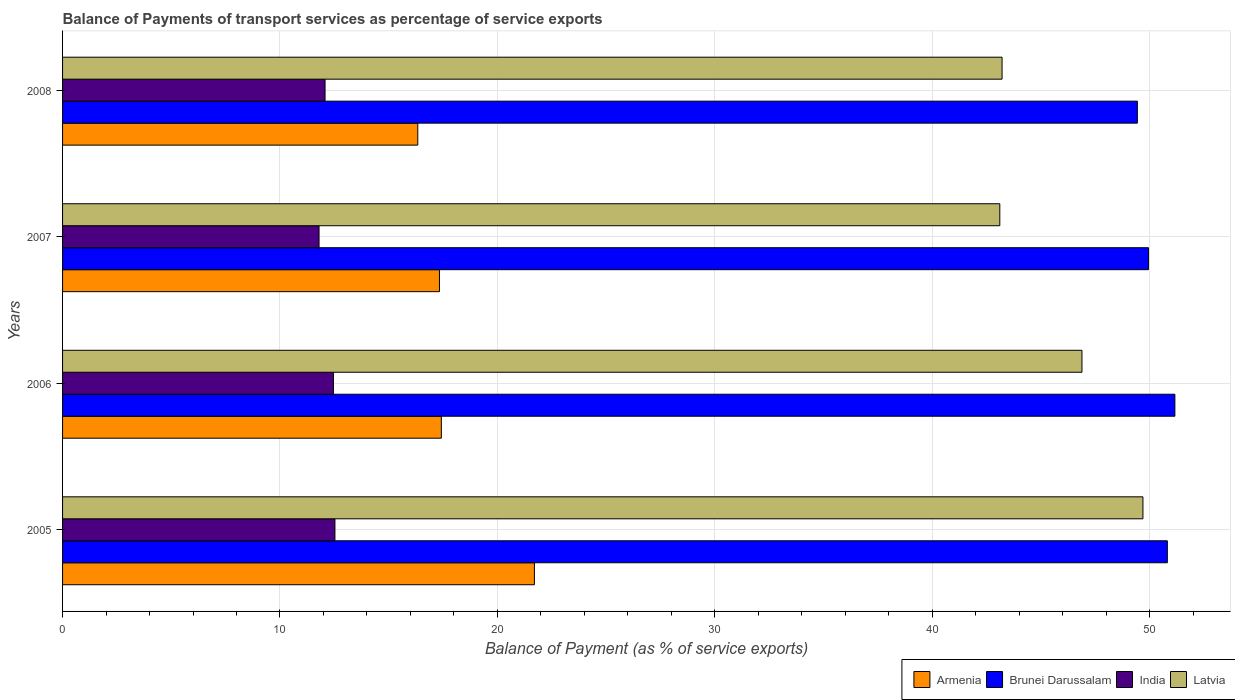How many groups of bars are there?
Make the answer very short. 4. Are the number of bars per tick equal to the number of legend labels?
Your response must be concise. Yes. Are the number of bars on each tick of the Y-axis equal?
Offer a terse response. Yes. How many bars are there on the 4th tick from the top?
Make the answer very short. 4. What is the balance of payments of transport services in India in 2007?
Your response must be concise. 11.8. Across all years, what is the maximum balance of payments of transport services in Armenia?
Keep it short and to the point. 21.7. Across all years, what is the minimum balance of payments of transport services in Latvia?
Keep it short and to the point. 43.11. In which year was the balance of payments of transport services in Brunei Darussalam maximum?
Your answer should be compact. 2006. In which year was the balance of payments of transport services in Latvia minimum?
Ensure brevity in your answer.  2007. What is the total balance of payments of transport services in Armenia in the graph?
Your response must be concise. 72.8. What is the difference between the balance of payments of transport services in Armenia in 2006 and that in 2007?
Ensure brevity in your answer.  0.09. What is the difference between the balance of payments of transport services in Brunei Darussalam in 2006 and the balance of payments of transport services in Latvia in 2005?
Keep it short and to the point. 1.47. What is the average balance of payments of transport services in India per year?
Give a very brief answer. 12.21. In the year 2008, what is the difference between the balance of payments of transport services in Latvia and balance of payments of transport services in India?
Keep it short and to the point. 31.14. In how many years, is the balance of payments of transport services in Brunei Darussalam greater than 26 %?
Your answer should be compact. 4. What is the ratio of the balance of payments of transport services in Brunei Darussalam in 2005 to that in 2006?
Give a very brief answer. 0.99. Is the balance of payments of transport services in India in 2005 less than that in 2006?
Give a very brief answer. No. Is the difference between the balance of payments of transport services in Latvia in 2006 and 2007 greater than the difference between the balance of payments of transport services in India in 2006 and 2007?
Your response must be concise. Yes. What is the difference between the highest and the second highest balance of payments of transport services in Latvia?
Give a very brief answer. 2.8. What is the difference between the highest and the lowest balance of payments of transport services in Brunei Darussalam?
Give a very brief answer. 1.73. In how many years, is the balance of payments of transport services in Latvia greater than the average balance of payments of transport services in Latvia taken over all years?
Ensure brevity in your answer.  2. Is the sum of the balance of payments of transport services in Brunei Darussalam in 2005 and 2006 greater than the maximum balance of payments of transport services in Latvia across all years?
Offer a very short reply. Yes. Is it the case that in every year, the sum of the balance of payments of transport services in Brunei Darussalam and balance of payments of transport services in Latvia is greater than the sum of balance of payments of transport services in Armenia and balance of payments of transport services in India?
Provide a short and direct response. Yes. What does the 4th bar from the top in 2007 represents?
Give a very brief answer. Armenia. What does the 2nd bar from the bottom in 2008 represents?
Provide a succinct answer. Brunei Darussalam. Are the values on the major ticks of X-axis written in scientific E-notation?
Ensure brevity in your answer.  No. Does the graph contain grids?
Ensure brevity in your answer.  Yes. How many legend labels are there?
Make the answer very short. 4. What is the title of the graph?
Provide a short and direct response. Balance of Payments of transport services as percentage of service exports. Does "Vanuatu" appear as one of the legend labels in the graph?
Offer a terse response. No. What is the label or title of the X-axis?
Provide a succinct answer. Balance of Payment (as % of service exports). What is the label or title of the Y-axis?
Ensure brevity in your answer.  Years. What is the Balance of Payment (as % of service exports) in Armenia in 2005?
Your response must be concise. 21.7. What is the Balance of Payment (as % of service exports) of Brunei Darussalam in 2005?
Provide a succinct answer. 50.81. What is the Balance of Payment (as % of service exports) of India in 2005?
Provide a succinct answer. 12.53. What is the Balance of Payment (as % of service exports) of Latvia in 2005?
Keep it short and to the point. 49.69. What is the Balance of Payment (as % of service exports) in Armenia in 2006?
Your answer should be very brief. 17.42. What is the Balance of Payment (as % of service exports) in Brunei Darussalam in 2006?
Provide a short and direct response. 51.16. What is the Balance of Payment (as % of service exports) in India in 2006?
Ensure brevity in your answer.  12.46. What is the Balance of Payment (as % of service exports) of Latvia in 2006?
Your answer should be very brief. 46.89. What is the Balance of Payment (as % of service exports) of Armenia in 2007?
Keep it short and to the point. 17.34. What is the Balance of Payment (as % of service exports) of Brunei Darussalam in 2007?
Your answer should be compact. 49.95. What is the Balance of Payment (as % of service exports) of India in 2007?
Keep it short and to the point. 11.8. What is the Balance of Payment (as % of service exports) of Latvia in 2007?
Give a very brief answer. 43.11. What is the Balance of Payment (as % of service exports) of Armenia in 2008?
Provide a short and direct response. 16.34. What is the Balance of Payment (as % of service exports) in Brunei Darussalam in 2008?
Give a very brief answer. 49.44. What is the Balance of Payment (as % of service exports) in India in 2008?
Your answer should be very brief. 12.07. What is the Balance of Payment (as % of service exports) of Latvia in 2008?
Offer a terse response. 43.21. Across all years, what is the maximum Balance of Payment (as % of service exports) of Armenia?
Your answer should be very brief. 21.7. Across all years, what is the maximum Balance of Payment (as % of service exports) in Brunei Darussalam?
Ensure brevity in your answer.  51.16. Across all years, what is the maximum Balance of Payment (as % of service exports) of India?
Make the answer very short. 12.53. Across all years, what is the maximum Balance of Payment (as % of service exports) of Latvia?
Ensure brevity in your answer.  49.69. Across all years, what is the minimum Balance of Payment (as % of service exports) of Armenia?
Your answer should be very brief. 16.34. Across all years, what is the minimum Balance of Payment (as % of service exports) of Brunei Darussalam?
Keep it short and to the point. 49.44. Across all years, what is the minimum Balance of Payment (as % of service exports) in India?
Your answer should be very brief. 11.8. Across all years, what is the minimum Balance of Payment (as % of service exports) in Latvia?
Keep it short and to the point. 43.11. What is the total Balance of Payment (as % of service exports) in Armenia in the graph?
Keep it short and to the point. 72.8. What is the total Balance of Payment (as % of service exports) of Brunei Darussalam in the graph?
Keep it short and to the point. 201.36. What is the total Balance of Payment (as % of service exports) in India in the graph?
Your answer should be compact. 48.86. What is the total Balance of Payment (as % of service exports) in Latvia in the graph?
Your answer should be compact. 182.9. What is the difference between the Balance of Payment (as % of service exports) in Armenia in 2005 and that in 2006?
Offer a very short reply. 4.28. What is the difference between the Balance of Payment (as % of service exports) of Brunei Darussalam in 2005 and that in 2006?
Ensure brevity in your answer.  -0.35. What is the difference between the Balance of Payment (as % of service exports) of India in 2005 and that in 2006?
Provide a short and direct response. 0.07. What is the difference between the Balance of Payment (as % of service exports) in Latvia in 2005 and that in 2006?
Give a very brief answer. 2.8. What is the difference between the Balance of Payment (as % of service exports) of Armenia in 2005 and that in 2007?
Keep it short and to the point. 4.37. What is the difference between the Balance of Payment (as % of service exports) in Brunei Darussalam in 2005 and that in 2007?
Your answer should be very brief. 0.86. What is the difference between the Balance of Payment (as % of service exports) of India in 2005 and that in 2007?
Give a very brief answer. 0.73. What is the difference between the Balance of Payment (as % of service exports) in Latvia in 2005 and that in 2007?
Offer a very short reply. 6.58. What is the difference between the Balance of Payment (as % of service exports) of Armenia in 2005 and that in 2008?
Your response must be concise. 5.36. What is the difference between the Balance of Payment (as % of service exports) of Brunei Darussalam in 2005 and that in 2008?
Provide a succinct answer. 1.38. What is the difference between the Balance of Payment (as % of service exports) of India in 2005 and that in 2008?
Your answer should be compact. 0.45. What is the difference between the Balance of Payment (as % of service exports) in Latvia in 2005 and that in 2008?
Your response must be concise. 6.48. What is the difference between the Balance of Payment (as % of service exports) in Armenia in 2006 and that in 2007?
Offer a very short reply. 0.09. What is the difference between the Balance of Payment (as % of service exports) in Brunei Darussalam in 2006 and that in 2007?
Your answer should be compact. 1.21. What is the difference between the Balance of Payment (as % of service exports) in India in 2006 and that in 2007?
Keep it short and to the point. 0.66. What is the difference between the Balance of Payment (as % of service exports) in Latvia in 2006 and that in 2007?
Provide a succinct answer. 3.78. What is the difference between the Balance of Payment (as % of service exports) of Armenia in 2006 and that in 2008?
Make the answer very short. 1.08. What is the difference between the Balance of Payment (as % of service exports) of Brunei Darussalam in 2006 and that in 2008?
Keep it short and to the point. 1.73. What is the difference between the Balance of Payment (as % of service exports) in India in 2006 and that in 2008?
Offer a terse response. 0.39. What is the difference between the Balance of Payment (as % of service exports) in Latvia in 2006 and that in 2008?
Your response must be concise. 3.67. What is the difference between the Balance of Payment (as % of service exports) of Armenia in 2007 and that in 2008?
Ensure brevity in your answer.  1. What is the difference between the Balance of Payment (as % of service exports) in Brunei Darussalam in 2007 and that in 2008?
Make the answer very short. 0.51. What is the difference between the Balance of Payment (as % of service exports) in India in 2007 and that in 2008?
Your answer should be very brief. -0.28. What is the difference between the Balance of Payment (as % of service exports) of Latvia in 2007 and that in 2008?
Offer a very short reply. -0.1. What is the difference between the Balance of Payment (as % of service exports) of Armenia in 2005 and the Balance of Payment (as % of service exports) of Brunei Darussalam in 2006?
Offer a terse response. -29.46. What is the difference between the Balance of Payment (as % of service exports) in Armenia in 2005 and the Balance of Payment (as % of service exports) in India in 2006?
Offer a very short reply. 9.24. What is the difference between the Balance of Payment (as % of service exports) of Armenia in 2005 and the Balance of Payment (as % of service exports) of Latvia in 2006?
Your answer should be compact. -25.18. What is the difference between the Balance of Payment (as % of service exports) in Brunei Darussalam in 2005 and the Balance of Payment (as % of service exports) in India in 2006?
Provide a succinct answer. 38.36. What is the difference between the Balance of Payment (as % of service exports) in Brunei Darussalam in 2005 and the Balance of Payment (as % of service exports) in Latvia in 2006?
Your answer should be compact. 3.93. What is the difference between the Balance of Payment (as % of service exports) in India in 2005 and the Balance of Payment (as % of service exports) in Latvia in 2006?
Your response must be concise. -34.36. What is the difference between the Balance of Payment (as % of service exports) in Armenia in 2005 and the Balance of Payment (as % of service exports) in Brunei Darussalam in 2007?
Your response must be concise. -28.25. What is the difference between the Balance of Payment (as % of service exports) in Armenia in 2005 and the Balance of Payment (as % of service exports) in India in 2007?
Provide a succinct answer. 9.91. What is the difference between the Balance of Payment (as % of service exports) of Armenia in 2005 and the Balance of Payment (as % of service exports) of Latvia in 2007?
Your answer should be compact. -21.41. What is the difference between the Balance of Payment (as % of service exports) in Brunei Darussalam in 2005 and the Balance of Payment (as % of service exports) in India in 2007?
Your answer should be compact. 39.02. What is the difference between the Balance of Payment (as % of service exports) of Brunei Darussalam in 2005 and the Balance of Payment (as % of service exports) of Latvia in 2007?
Your answer should be compact. 7.71. What is the difference between the Balance of Payment (as % of service exports) of India in 2005 and the Balance of Payment (as % of service exports) of Latvia in 2007?
Ensure brevity in your answer.  -30.58. What is the difference between the Balance of Payment (as % of service exports) in Armenia in 2005 and the Balance of Payment (as % of service exports) in Brunei Darussalam in 2008?
Provide a succinct answer. -27.73. What is the difference between the Balance of Payment (as % of service exports) in Armenia in 2005 and the Balance of Payment (as % of service exports) in India in 2008?
Your answer should be very brief. 9.63. What is the difference between the Balance of Payment (as % of service exports) in Armenia in 2005 and the Balance of Payment (as % of service exports) in Latvia in 2008?
Offer a very short reply. -21.51. What is the difference between the Balance of Payment (as % of service exports) of Brunei Darussalam in 2005 and the Balance of Payment (as % of service exports) of India in 2008?
Provide a succinct answer. 38.74. What is the difference between the Balance of Payment (as % of service exports) in Brunei Darussalam in 2005 and the Balance of Payment (as % of service exports) in Latvia in 2008?
Make the answer very short. 7.6. What is the difference between the Balance of Payment (as % of service exports) in India in 2005 and the Balance of Payment (as % of service exports) in Latvia in 2008?
Provide a short and direct response. -30.68. What is the difference between the Balance of Payment (as % of service exports) in Armenia in 2006 and the Balance of Payment (as % of service exports) in Brunei Darussalam in 2007?
Ensure brevity in your answer.  -32.53. What is the difference between the Balance of Payment (as % of service exports) in Armenia in 2006 and the Balance of Payment (as % of service exports) in India in 2007?
Keep it short and to the point. 5.62. What is the difference between the Balance of Payment (as % of service exports) in Armenia in 2006 and the Balance of Payment (as % of service exports) in Latvia in 2007?
Offer a very short reply. -25.69. What is the difference between the Balance of Payment (as % of service exports) of Brunei Darussalam in 2006 and the Balance of Payment (as % of service exports) of India in 2007?
Your response must be concise. 39.36. What is the difference between the Balance of Payment (as % of service exports) in Brunei Darussalam in 2006 and the Balance of Payment (as % of service exports) in Latvia in 2007?
Give a very brief answer. 8.05. What is the difference between the Balance of Payment (as % of service exports) of India in 2006 and the Balance of Payment (as % of service exports) of Latvia in 2007?
Your response must be concise. -30.65. What is the difference between the Balance of Payment (as % of service exports) of Armenia in 2006 and the Balance of Payment (as % of service exports) of Brunei Darussalam in 2008?
Offer a very short reply. -32.01. What is the difference between the Balance of Payment (as % of service exports) of Armenia in 2006 and the Balance of Payment (as % of service exports) of India in 2008?
Provide a succinct answer. 5.35. What is the difference between the Balance of Payment (as % of service exports) in Armenia in 2006 and the Balance of Payment (as % of service exports) in Latvia in 2008?
Ensure brevity in your answer.  -25.79. What is the difference between the Balance of Payment (as % of service exports) of Brunei Darussalam in 2006 and the Balance of Payment (as % of service exports) of India in 2008?
Your answer should be compact. 39.09. What is the difference between the Balance of Payment (as % of service exports) in Brunei Darussalam in 2006 and the Balance of Payment (as % of service exports) in Latvia in 2008?
Ensure brevity in your answer.  7.95. What is the difference between the Balance of Payment (as % of service exports) in India in 2006 and the Balance of Payment (as % of service exports) in Latvia in 2008?
Provide a succinct answer. -30.75. What is the difference between the Balance of Payment (as % of service exports) of Armenia in 2007 and the Balance of Payment (as % of service exports) of Brunei Darussalam in 2008?
Offer a terse response. -32.1. What is the difference between the Balance of Payment (as % of service exports) in Armenia in 2007 and the Balance of Payment (as % of service exports) in India in 2008?
Ensure brevity in your answer.  5.26. What is the difference between the Balance of Payment (as % of service exports) in Armenia in 2007 and the Balance of Payment (as % of service exports) in Latvia in 2008?
Offer a very short reply. -25.88. What is the difference between the Balance of Payment (as % of service exports) in Brunei Darussalam in 2007 and the Balance of Payment (as % of service exports) in India in 2008?
Your answer should be compact. 37.88. What is the difference between the Balance of Payment (as % of service exports) of Brunei Darussalam in 2007 and the Balance of Payment (as % of service exports) of Latvia in 2008?
Your answer should be very brief. 6.74. What is the difference between the Balance of Payment (as % of service exports) of India in 2007 and the Balance of Payment (as % of service exports) of Latvia in 2008?
Your response must be concise. -31.41. What is the average Balance of Payment (as % of service exports) of Armenia per year?
Offer a terse response. 18.2. What is the average Balance of Payment (as % of service exports) of Brunei Darussalam per year?
Provide a short and direct response. 50.34. What is the average Balance of Payment (as % of service exports) in India per year?
Offer a very short reply. 12.21. What is the average Balance of Payment (as % of service exports) of Latvia per year?
Give a very brief answer. 45.72. In the year 2005, what is the difference between the Balance of Payment (as % of service exports) of Armenia and Balance of Payment (as % of service exports) of Brunei Darussalam?
Provide a succinct answer. -29.11. In the year 2005, what is the difference between the Balance of Payment (as % of service exports) of Armenia and Balance of Payment (as % of service exports) of India?
Your response must be concise. 9.17. In the year 2005, what is the difference between the Balance of Payment (as % of service exports) of Armenia and Balance of Payment (as % of service exports) of Latvia?
Give a very brief answer. -27.99. In the year 2005, what is the difference between the Balance of Payment (as % of service exports) of Brunei Darussalam and Balance of Payment (as % of service exports) of India?
Provide a succinct answer. 38.29. In the year 2005, what is the difference between the Balance of Payment (as % of service exports) of Brunei Darussalam and Balance of Payment (as % of service exports) of Latvia?
Offer a terse response. 1.12. In the year 2005, what is the difference between the Balance of Payment (as % of service exports) in India and Balance of Payment (as % of service exports) in Latvia?
Keep it short and to the point. -37.16. In the year 2006, what is the difference between the Balance of Payment (as % of service exports) of Armenia and Balance of Payment (as % of service exports) of Brunei Darussalam?
Your answer should be very brief. -33.74. In the year 2006, what is the difference between the Balance of Payment (as % of service exports) in Armenia and Balance of Payment (as % of service exports) in India?
Make the answer very short. 4.96. In the year 2006, what is the difference between the Balance of Payment (as % of service exports) in Armenia and Balance of Payment (as % of service exports) in Latvia?
Give a very brief answer. -29.46. In the year 2006, what is the difference between the Balance of Payment (as % of service exports) of Brunei Darussalam and Balance of Payment (as % of service exports) of India?
Give a very brief answer. 38.7. In the year 2006, what is the difference between the Balance of Payment (as % of service exports) in Brunei Darussalam and Balance of Payment (as % of service exports) in Latvia?
Offer a terse response. 4.27. In the year 2006, what is the difference between the Balance of Payment (as % of service exports) of India and Balance of Payment (as % of service exports) of Latvia?
Your answer should be compact. -34.43. In the year 2007, what is the difference between the Balance of Payment (as % of service exports) in Armenia and Balance of Payment (as % of service exports) in Brunei Darussalam?
Make the answer very short. -32.61. In the year 2007, what is the difference between the Balance of Payment (as % of service exports) of Armenia and Balance of Payment (as % of service exports) of India?
Provide a short and direct response. 5.54. In the year 2007, what is the difference between the Balance of Payment (as % of service exports) in Armenia and Balance of Payment (as % of service exports) in Latvia?
Provide a succinct answer. -25.77. In the year 2007, what is the difference between the Balance of Payment (as % of service exports) of Brunei Darussalam and Balance of Payment (as % of service exports) of India?
Provide a short and direct response. 38.15. In the year 2007, what is the difference between the Balance of Payment (as % of service exports) of Brunei Darussalam and Balance of Payment (as % of service exports) of Latvia?
Make the answer very short. 6.84. In the year 2007, what is the difference between the Balance of Payment (as % of service exports) in India and Balance of Payment (as % of service exports) in Latvia?
Your answer should be very brief. -31.31. In the year 2008, what is the difference between the Balance of Payment (as % of service exports) in Armenia and Balance of Payment (as % of service exports) in Brunei Darussalam?
Provide a succinct answer. -33.1. In the year 2008, what is the difference between the Balance of Payment (as % of service exports) of Armenia and Balance of Payment (as % of service exports) of India?
Provide a succinct answer. 4.26. In the year 2008, what is the difference between the Balance of Payment (as % of service exports) of Armenia and Balance of Payment (as % of service exports) of Latvia?
Give a very brief answer. -26.87. In the year 2008, what is the difference between the Balance of Payment (as % of service exports) of Brunei Darussalam and Balance of Payment (as % of service exports) of India?
Give a very brief answer. 37.36. In the year 2008, what is the difference between the Balance of Payment (as % of service exports) in Brunei Darussalam and Balance of Payment (as % of service exports) in Latvia?
Offer a terse response. 6.22. In the year 2008, what is the difference between the Balance of Payment (as % of service exports) in India and Balance of Payment (as % of service exports) in Latvia?
Your answer should be compact. -31.14. What is the ratio of the Balance of Payment (as % of service exports) in Armenia in 2005 to that in 2006?
Offer a very short reply. 1.25. What is the ratio of the Balance of Payment (as % of service exports) of Brunei Darussalam in 2005 to that in 2006?
Offer a very short reply. 0.99. What is the ratio of the Balance of Payment (as % of service exports) of India in 2005 to that in 2006?
Provide a succinct answer. 1.01. What is the ratio of the Balance of Payment (as % of service exports) of Latvia in 2005 to that in 2006?
Your answer should be very brief. 1.06. What is the ratio of the Balance of Payment (as % of service exports) in Armenia in 2005 to that in 2007?
Your answer should be very brief. 1.25. What is the ratio of the Balance of Payment (as % of service exports) in Brunei Darussalam in 2005 to that in 2007?
Offer a very short reply. 1.02. What is the ratio of the Balance of Payment (as % of service exports) in India in 2005 to that in 2007?
Give a very brief answer. 1.06. What is the ratio of the Balance of Payment (as % of service exports) of Latvia in 2005 to that in 2007?
Give a very brief answer. 1.15. What is the ratio of the Balance of Payment (as % of service exports) of Armenia in 2005 to that in 2008?
Your answer should be compact. 1.33. What is the ratio of the Balance of Payment (as % of service exports) of Brunei Darussalam in 2005 to that in 2008?
Your answer should be compact. 1.03. What is the ratio of the Balance of Payment (as % of service exports) of India in 2005 to that in 2008?
Your answer should be very brief. 1.04. What is the ratio of the Balance of Payment (as % of service exports) in Latvia in 2005 to that in 2008?
Provide a short and direct response. 1.15. What is the ratio of the Balance of Payment (as % of service exports) of Brunei Darussalam in 2006 to that in 2007?
Offer a terse response. 1.02. What is the ratio of the Balance of Payment (as % of service exports) of India in 2006 to that in 2007?
Ensure brevity in your answer.  1.06. What is the ratio of the Balance of Payment (as % of service exports) of Latvia in 2006 to that in 2007?
Offer a terse response. 1.09. What is the ratio of the Balance of Payment (as % of service exports) in Armenia in 2006 to that in 2008?
Your response must be concise. 1.07. What is the ratio of the Balance of Payment (as % of service exports) in Brunei Darussalam in 2006 to that in 2008?
Your answer should be very brief. 1.03. What is the ratio of the Balance of Payment (as % of service exports) in India in 2006 to that in 2008?
Offer a very short reply. 1.03. What is the ratio of the Balance of Payment (as % of service exports) in Latvia in 2006 to that in 2008?
Keep it short and to the point. 1.08. What is the ratio of the Balance of Payment (as % of service exports) of Armenia in 2007 to that in 2008?
Your response must be concise. 1.06. What is the ratio of the Balance of Payment (as % of service exports) in Brunei Darussalam in 2007 to that in 2008?
Ensure brevity in your answer.  1.01. What is the ratio of the Balance of Payment (as % of service exports) of India in 2007 to that in 2008?
Ensure brevity in your answer.  0.98. What is the difference between the highest and the second highest Balance of Payment (as % of service exports) in Armenia?
Make the answer very short. 4.28. What is the difference between the highest and the second highest Balance of Payment (as % of service exports) of Brunei Darussalam?
Give a very brief answer. 0.35. What is the difference between the highest and the second highest Balance of Payment (as % of service exports) of India?
Give a very brief answer. 0.07. What is the difference between the highest and the second highest Balance of Payment (as % of service exports) in Latvia?
Your answer should be compact. 2.8. What is the difference between the highest and the lowest Balance of Payment (as % of service exports) in Armenia?
Your answer should be very brief. 5.36. What is the difference between the highest and the lowest Balance of Payment (as % of service exports) in Brunei Darussalam?
Offer a very short reply. 1.73. What is the difference between the highest and the lowest Balance of Payment (as % of service exports) of India?
Your response must be concise. 0.73. What is the difference between the highest and the lowest Balance of Payment (as % of service exports) in Latvia?
Give a very brief answer. 6.58. 